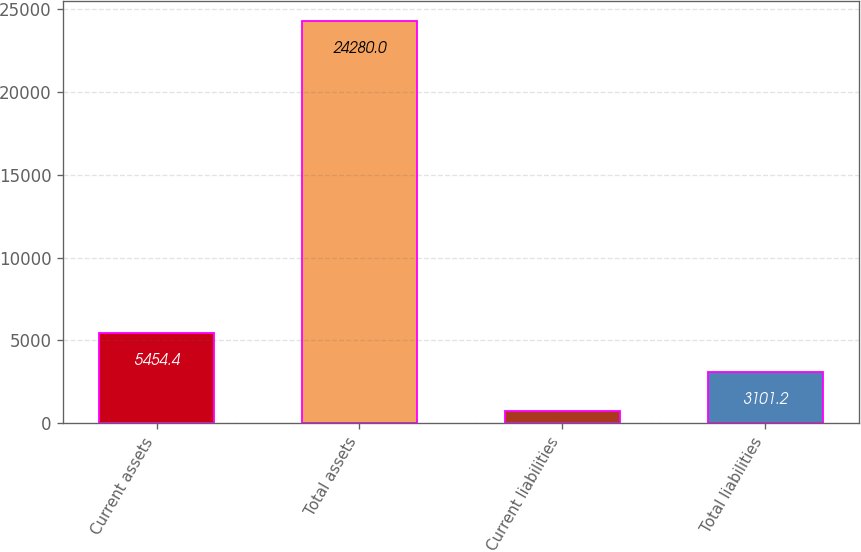<chart> <loc_0><loc_0><loc_500><loc_500><bar_chart><fcel>Current assets<fcel>Total assets<fcel>Current liabilities<fcel>Total liabilities<nl><fcel>5454.4<fcel>24280<fcel>748<fcel>3101.2<nl></chart> 